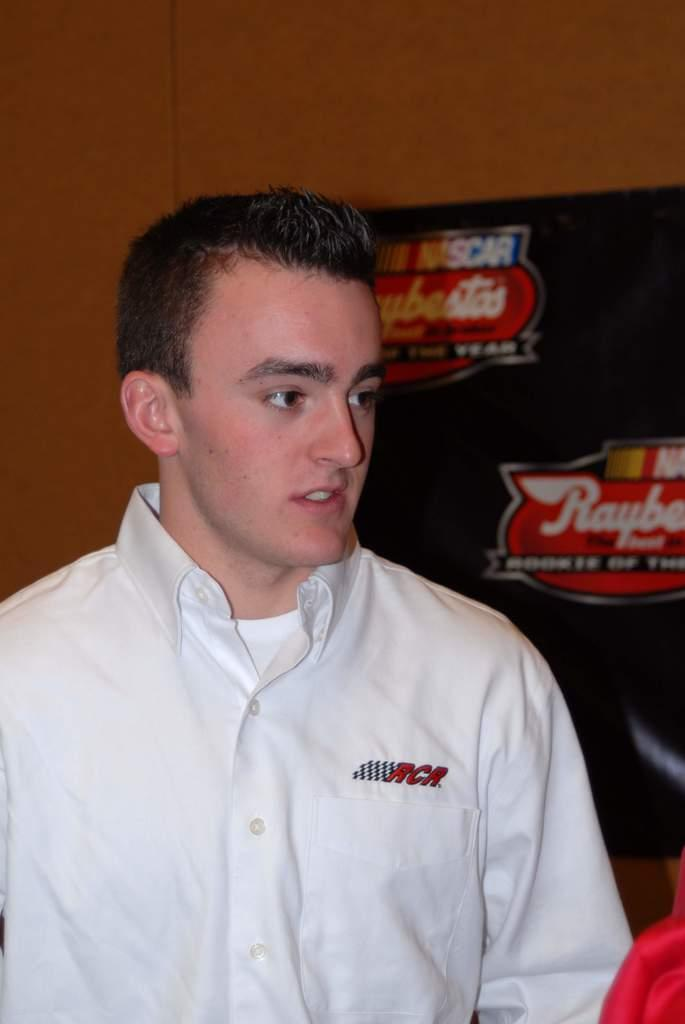Provide a one-sentence caption for the provided image. An RCR employee is standing in front of board promoting Nascar. 